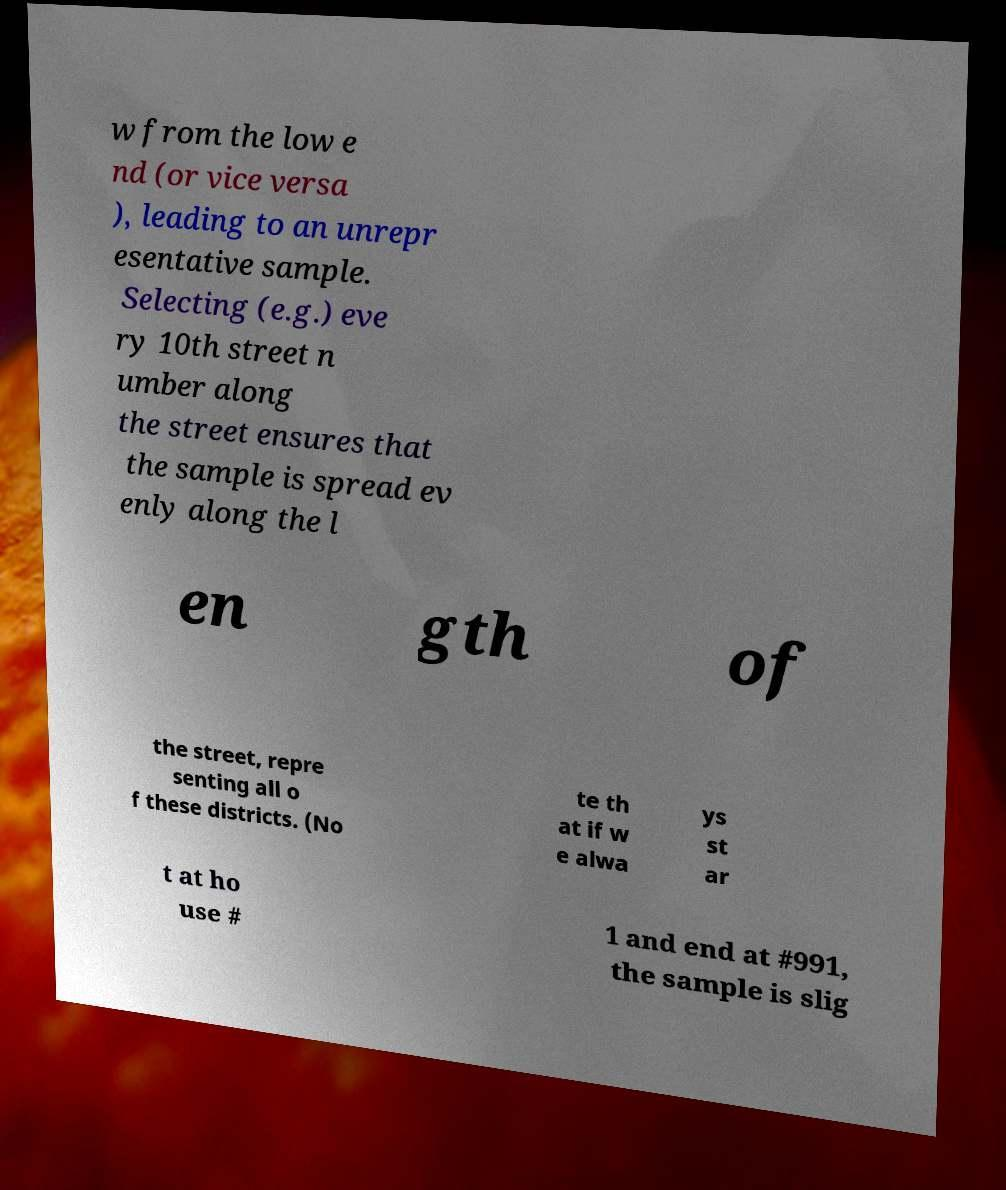Could you extract and type out the text from this image? w from the low e nd (or vice versa ), leading to an unrepr esentative sample. Selecting (e.g.) eve ry 10th street n umber along the street ensures that the sample is spread ev enly along the l en gth of the street, repre senting all o f these districts. (No te th at if w e alwa ys st ar t at ho use # 1 and end at #991, the sample is slig 